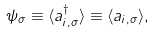Convert formula to latex. <formula><loc_0><loc_0><loc_500><loc_500>\psi _ { \sigma } \equiv \langle a ^ { \dagger } _ { i , \sigma } \rangle \equiv \langle a _ { i , \sigma } \rangle ,</formula> 